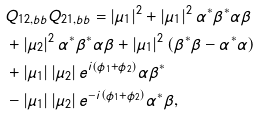Convert formula to latex. <formula><loc_0><loc_0><loc_500><loc_500>& Q _ { 1 2 , b b } Q _ { 2 1 , b b } = \left | \mu _ { 1 } \right | ^ { 2 } + \left | \mu _ { 1 } \right | ^ { 2 } \alpha ^ { \ast } \beta ^ { \ast } \alpha \beta \\ & + \left | \mu _ { 2 } \right | ^ { 2 } \alpha ^ { \ast } \beta ^ { \ast } \alpha \beta + \left | \mu _ { 1 } \right | ^ { 2 } \left ( \beta ^ { \ast } \beta - \alpha ^ { \ast } \alpha \right ) \\ & + \left | \mu _ { 1 } \right | \left | \mu _ { 2 } \right | e ^ { i \left ( \phi _ { 1 } + \phi _ { 2 } \right ) } \alpha \beta ^ { \ast } \\ & - \left | \mu _ { 1 } \right | \left | \mu _ { 2 } \right | e ^ { - i \left ( \phi _ { 1 } + \phi _ { 2 } \right ) } \alpha ^ { \ast } \beta ,</formula> 